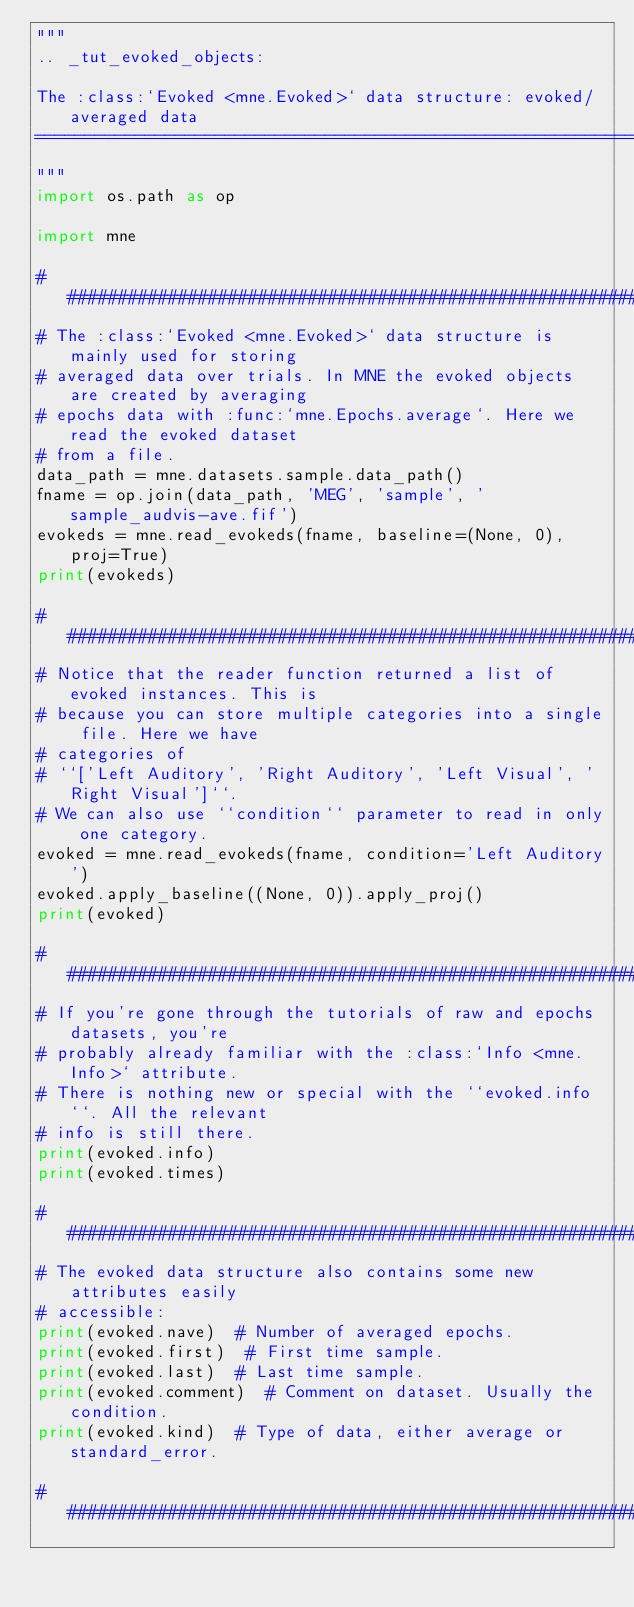<code> <loc_0><loc_0><loc_500><loc_500><_Python_>"""
.. _tut_evoked_objects:

The :class:`Evoked <mne.Evoked>` data structure: evoked/averaged data
=====================================================================
"""
import os.path as op

import mne

###############################################################################
# The :class:`Evoked <mne.Evoked>` data structure is mainly used for storing
# averaged data over trials. In MNE the evoked objects are created by averaging
# epochs data with :func:`mne.Epochs.average`. Here we read the evoked dataset
# from a file.
data_path = mne.datasets.sample.data_path()
fname = op.join(data_path, 'MEG', 'sample', 'sample_audvis-ave.fif')
evokeds = mne.read_evokeds(fname, baseline=(None, 0), proj=True)
print(evokeds)

###############################################################################
# Notice that the reader function returned a list of evoked instances. This is
# because you can store multiple categories into a single file. Here we have
# categories of
# ``['Left Auditory', 'Right Auditory', 'Left Visual', 'Right Visual']``.
# We can also use ``condition`` parameter to read in only one category.
evoked = mne.read_evokeds(fname, condition='Left Auditory')
evoked.apply_baseline((None, 0)).apply_proj()
print(evoked)

###############################################################################
# If you're gone through the tutorials of raw and epochs datasets, you're
# probably already familiar with the :class:`Info <mne.Info>` attribute.
# There is nothing new or special with the ``evoked.info``. All the relevant
# info is still there.
print(evoked.info)
print(evoked.times)

###############################################################################
# The evoked data structure also contains some new attributes easily
# accessible:
print(evoked.nave)  # Number of averaged epochs.
print(evoked.first)  # First time sample.
print(evoked.last)  # Last time sample.
print(evoked.comment)  # Comment on dataset. Usually the condition.
print(evoked.kind)  # Type of data, either average or standard_error.

###############################################################################</code> 